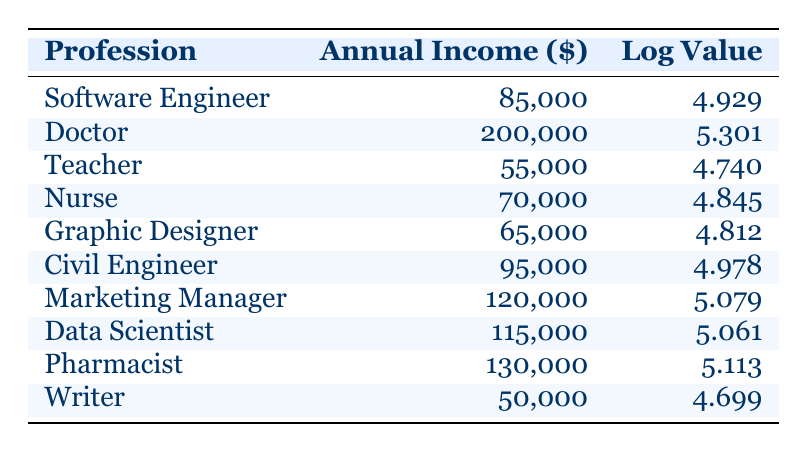What is the highest annual income listed in the table? The table shows various professions along with their annual incomes. Scanning through the 'Annual Income' column, I see that the highest value is 200000, associated with the profession of Doctor.
Answer: 200000 Which profession has an annual income closest to 100000? I will look through the annual income values: Software Engineer has 85000, Civil Engineer has 95000, Data Scientist has 115000, and Marketing Manager has 120000. The closest annual income to 100000 is 95000 for Civil Engineer.
Answer: Civil Engineer Is the annual income of a Writer greater than that of a Nurse? The annual income listed for Writer is 50000 and for Nurse is 70000. Since 50000 is less than 70000, the statement is false.
Answer: No What is the average annual income of the professionals represented in the table? To find the average, I sum all annual incomes: 85000 + 200000 + 55000 + 70000 + 65000 + 95000 + 120000 + 115000 + 130000 + 50000 = 915000. There are 10 professions, so the average is 915000 / 10 = 91500.
Answer: 91500 Are there more professions listed that earn above 100000 than below? The incomes above 100000 are for Doctor, Marketing Manager, Data Scientist, and Pharmacist (4 professions), while below 100000 are Software Engineer, Teacher, Nurse, Graphic Designer, and Writer (6 professions). Since 6 is greater than 4, the answer is no.
Answer: No Which profession has the lowest logarithmic value in the table? Scanning the 'Log Value' column, the lowest is 4.699 for Writer. This is confirmed by comparing the log values of all professions listed.
Answer: Writer If we sum the annual incomes of Teachers, Nurses, and Graphic Designers, what is the total? The annual incomes for these professions are: Teacher 55000, Nurse 70000, and Graphic Designer 65000. Summing these gives: 55000 + 70000 + 65000 = 190000.
Answer: 190000 What is the difference in annual income between the highest and lowest earning professions? The highest earning profession is Doctor with 200000 and the lowest is Writer with 50000. The difference is calculated as 200000 - 50000 = 150000.
Answer: 150000 What percentage of the total annual income is represented by the Data Scientist profession? First, calculate the total annual income which is 915000. Then, find the income for Data Scientist which is 115000. The percentage is (115000 / 915000) * 100, which equals approximately 12.57%.
Answer: 12.57% 